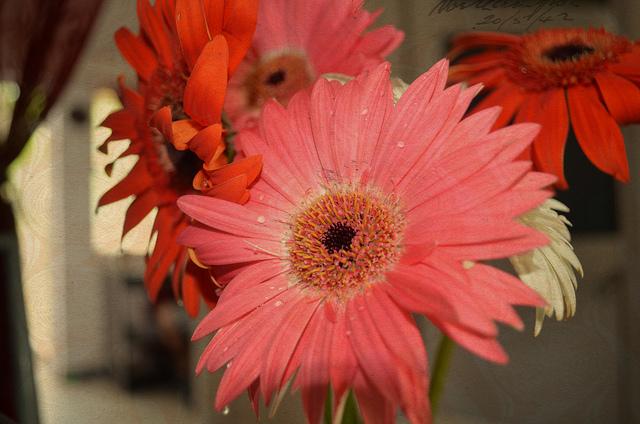How many petals on the pink flower?
Write a very short answer. 40. How many flowers are in the picture?
Be succinct. 4. What color is the closest flower?
Concise answer only. Pink. 